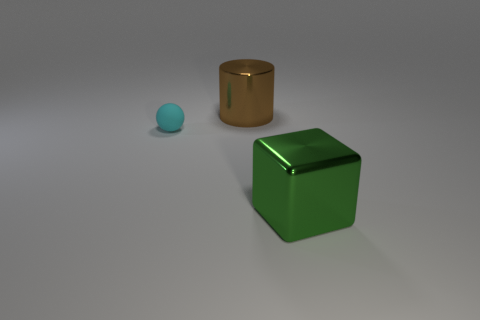Add 2 brown shiny objects. How many objects exist? 5 Add 2 big cyan metal cylinders. How many big cyan metal cylinders exist? 2 Subtract 0 red cylinders. How many objects are left? 3 Subtract all blocks. How many objects are left? 2 Subtract 1 blocks. How many blocks are left? 0 Subtract all brown balls. Subtract all blue blocks. How many balls are left? 1 Subtract all spheres. Subtract all green metal objects. How many objects are left? 1 Add 1 big blocks. How many big blocks are left? 2 